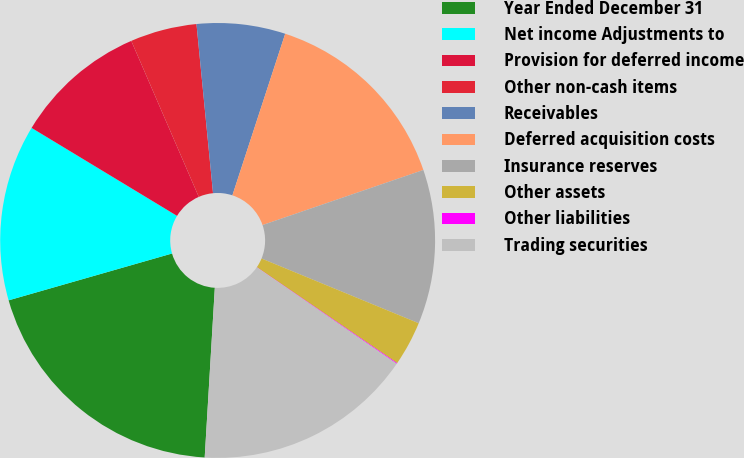Convert chart to OTSL. <chart><loc_0><loc_0><loc_500><loc_500><pie_chart><fcel>Year Ended December 31<fcel>Net income Adjustments to<fcel>Provision for deferred income<fcel>Other non-cash items<fcel>Receivables<fcel>Deferred acquisition costs<fcel>Insurance reserves<fcel>Other assets<fcel>Other liabilities<fcel>Trading securities<nl><fcel>19.61%<fcel>13.1%<fcel>9.84%<fcel>4.95%<fcel>6.58%<fcel>14.72%<fcel>11.47%<fcel>3.32%<fcel>0.06%<fcel>16.35%<nl></chart> 